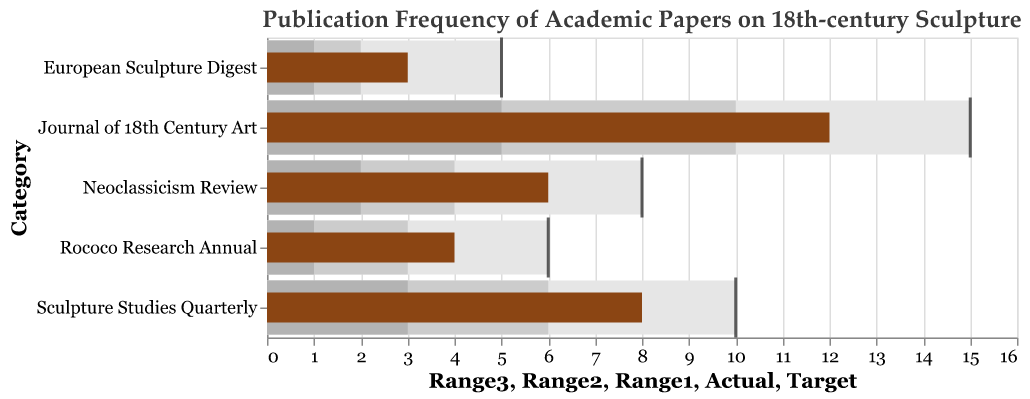What's the title of the figure? The title is located at the top of the figure, usually describing the main content
Answer: Publication Frequency of Academic Papers on 18th-century Sculpture What is the color of the target markers? Target markers are represented by tick marks which are colored in black
Answer: Black Which journal has the highest actual publication frequency? The actual publication frequency is represented by the length of the brown bars. Among all categories, "Journal of 18th Century Art" has the longest bar at 12
Answer: Journal of 18th Century Art How many journals exceeded their Target publication frequency? To determine this, compare the actual publication frequency (brown bar) with the target (black tick mark) for each journal. None of the journals have an actual frequency that exceeds the target
Answer: 0 What is the difference between the Target and Actual publication frequency for the "European Sculpture Digest"? The target for "European Sculpture Digest" is 5, and the actual is 3. The difference is 5 - 3
Answer: 2 Which journal falls the most short of reaching its target? To find this, calculate the absolute differences between the Actual and Target values for each journal. "Journal of 18th Century Art" falls 3 short of its target of 15, which is the largest difference
Answer: Journal of 18th Century Art What ranges are defined within the Bullet Chart, and what colors represent them? The ranges are defined to show different levels of performance. Light gray color represents the lowest range, medium gray represents the mid-range, and dark gray represents the highest range.
Answer: Light Gray: Range1, Medium Gray: Range2, Dark Gray: Range3 Which journal has an actual publication frequency within its highest defined range? Check the Actual publication frequency compared to Range3 for each journal. "Journal of 18th Century Art" has an Actual frequency of 12, which is within its highest defined range of up to 15
Answer: Journal of 18th Century Art Calculate the average Target publication frequency across all journals Sum the Target frequencies and divide by the number of journals. (15 + 10 + 8 + 6 + 5) / 5 = 44/5
Answer: 8.8 Compare the actual frequency of "Sculpture Studies Quarterly" and "Neoclassicism Review". Which is higher? Compare the actual frequencies of the two journals, where "Sculpture Studies Quarterly" has an actual frequency of 8 and "Neoclassicism Review" has 6. 8 is higher than 6
Answer: Sculpture Studies Quarterly 